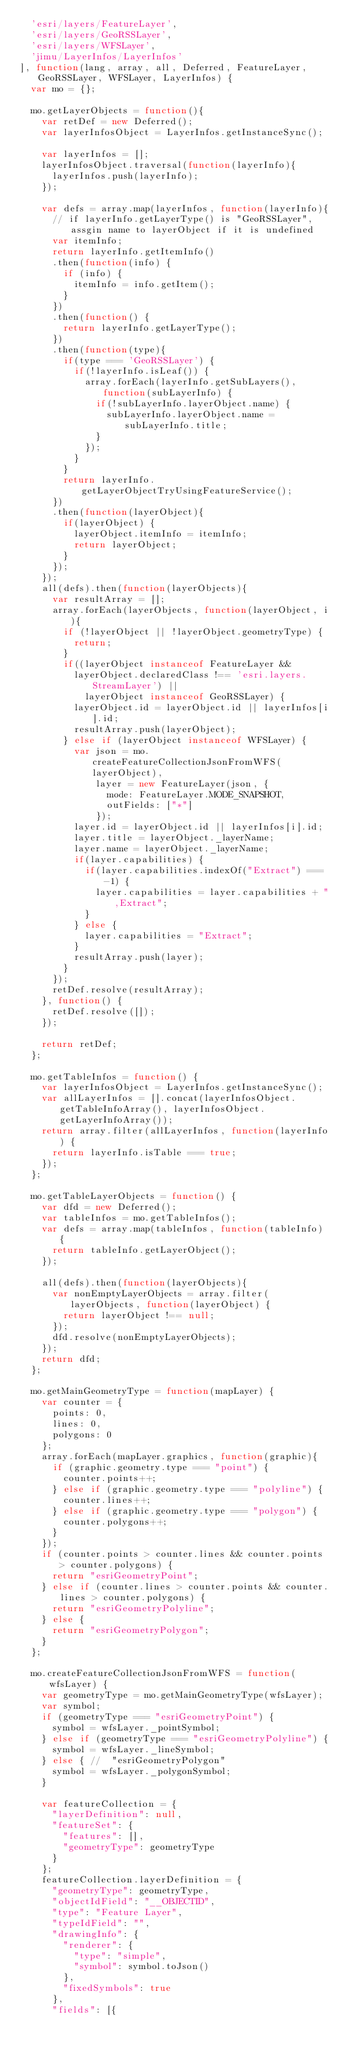<code> <loc_0><loc_0><loc_500><loc_500><_JavaScript_>  'esri/layers/FeatureLayer',
  'esri/layers/GeoRSSLayer',
  'esri/layers/WFSLayer',
  'jimu/LayerInfos/LayerInfos'
], function(lang, array, all, Deferred, FeatureLayer, GeoRSSLayer, WFSLayer, LayerInfos) {
  var mo = {};

  mo.getLayerObjects = function(){
    var retDef = new Deferred();
    var layerInfosObject = LayerInfos.getInstanceSync();

    var layerInfos = [];
    layerInfosObject.traversal(function(layerInfo){
      layerInfos.push(layerInfo);
    });

    var defs = array.map(layerInfos, function(layerInfo){
      // if layerInfo.getLayerType() is "GeoRSSLayer", assgin name to layerObject if it is undefined
      var itemInfo;
      return layerInfo.getItemInfo()
      .then(function(info) {
        if (info) {
          itemInfo = info.getItem();
        }
      })
      .then(function() {
        return layerInfo.getLayerType();
      })
      .then(function(type){
        if(type === 'GeoRSSLayer') {
          if(!layerInfo.isLeaf()) {
            array.forEach(layerInfo.getSubLayers(), function(subLayerInfo) {
              if(!subLayerInfo.layerObject.name) {
                subLayerInfo.layerObject.name = subLayerInfo.title;
              }
            });
          }
        }
        return layerInfo.getLayerObjectTryUsingFeatureService();
      })
      .then(function(layerObject){
        if(layerObject) {
          layerObject.itemInfo = itemInfo;
          return layerObject;
        }
      });
    });
    all(defs).then(function(layerObjects){
      var resultArray = [];
      array.forEach(layerObjects, function(layerObject, i){
        if (!layerObject || !layerObject.geometryType) {
          return;
        }
        if((layerObject instanceof FeatureLayer &&
          layerObject.declaredClass !== 'esri.layers.StreamLayer') ||
            layerObject instanceof GeoRSSLayer) {
          layerObject.id = layerObject.id || layerInfos[i].id;
          resultArray.push(layerObject);
        } else if (layerObject instanceof WFSLayer) {
          var json = mo.createFeatureCollectionJsonFromWFS(layerObject),
              layer = new FeatureLayer(json, {
                mode: FeatureLayer.MODE_SNAPSHOT,
                outFields: ["*"]
              });
          layer.id = layerObject.id || layerInfos[i].id;
          layer.title = layerObject._layerName;
          layer.name = layerObject._layerName;
          if(layer.capabilities) {
            if(layer.capabilities.indexOf("Extract") === -1) {
              layer.capabilities = layer.capabilities + ",Extract";
            }
          } else {
            layer.capabilities = "Extract";
          }
          resultArray.push(layer);
        }
      });
      retDef.resolve(resultArray);
    }, function() {
      retDef.resolve([]);
    });

    return retDef;
  };

  mo.getTableInfos = function() {
    var layerInfosObject = LayerInfos.getInstanceSync();
    var allLayerInfos = [].concat(layerInfosObject.getTableInfoArray(), layerInfosObject.getLayerInfoArray());
    return array.filter(allLayerInfos, function(layerInfo) {
      return layerInfo.isTable === true;
    });
  };

  mo.getTableLayerObjects = function() {
    var dfd = new Deferred();
    var tableInfos = mo.getTableInfos();
    var defs = array.map(tableInfos, function(tableInfo) {
      return tableInfo.getLayerObject();
    });

    all(defs).then(function(layerObjects){
      var nonEmptyLayerObjects = array.filter(layerObjects, function(layerObject) {
        return layerObject !== null;
      });
      dfd.resolve(nonEmptyLayerObjects);
    });
    return dfd;
  };

  mo.getMainGeometryType = function(mapLayer) {
    var counter = {
      points: 0,
      lines: 0,
      polygons: 0
    };
    array.forEach(mapLayer.graphics, function(graphic){
      if (graphic.geometry.type === "point") {
        counter.points++;
      } else if (graphic.geometry.type === "polyline") {
        counter.lines++;
      } else if (graphic.geometry.type === "polygon") {
        counter.polygons++;
      }
    });
    if (counter.points > counter.lines && counter.points > counter.polygons) {
      return "esriGeometryPoint";
    } else if (counter.lines > counter.points && counter.lines > counter.polygons) {
      return "esriGeometryPolyline";
    } else {
      return "esriGeometryPolygon";
    }
  };

  mo.createFeatureCollectionJsonFromWFS = function(wfsLayer) {
    var geometryType = mo.getMainGeometryType(wfsLayer);
    var symbol;
    if (geometryType === "esriGeometryPoint") {
      symbol = wfsLayer._pointSymbol;
    } else if (geometryType === "esriGeometryPolyline") {
      symbol = wfsLayer._lineSymbol;
    } else { //  "esriGeometryPolygon"
      symbol = wfsLayer._polygonSymbol;
    }

    var featureCollection = {
      "layerDefinition": null,
      "featureSet": {
        "features": [],
        "geometryType": geometryType
      }
    };
    featureCollection.layerDefinition = {
      "geometryType": geometryType,
      "objectIdField": "__OBJECTID",
      "type": "Feature Layer",
      "typeIdField": "",
      "drawingInfo": {
        "renderer": {
          "type": "simple",
          "symbol": symbol.toJson()
        },
        "fixedSymbols": true
      },
      "fields": [{</code> 